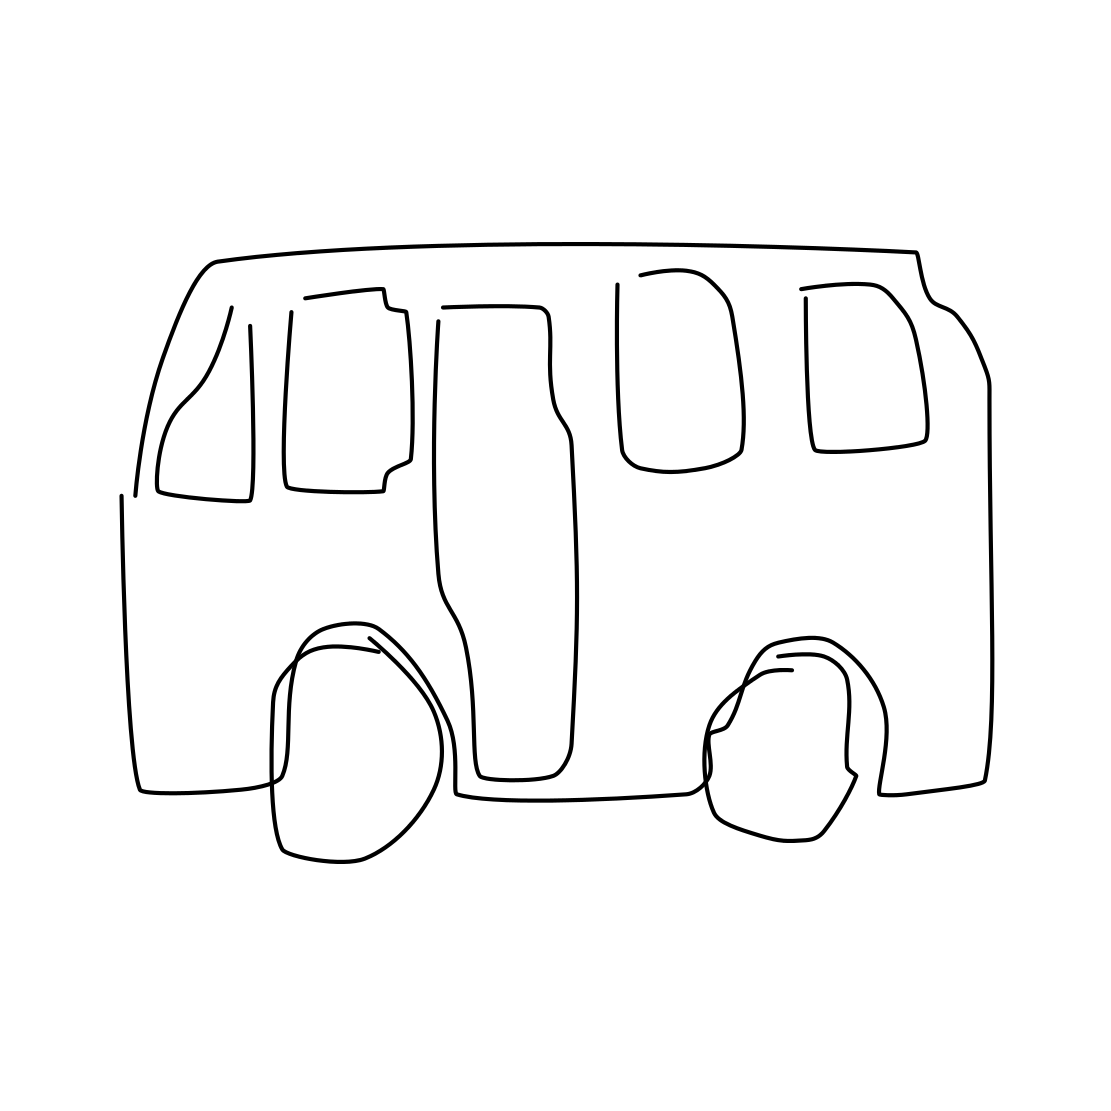In the scene, is there a rifle in it? After a thorough observation of the scene, I can confirm that there is no rifle present. What you see is a simplistic line drawing of a vehicle, closely resembling a van. 